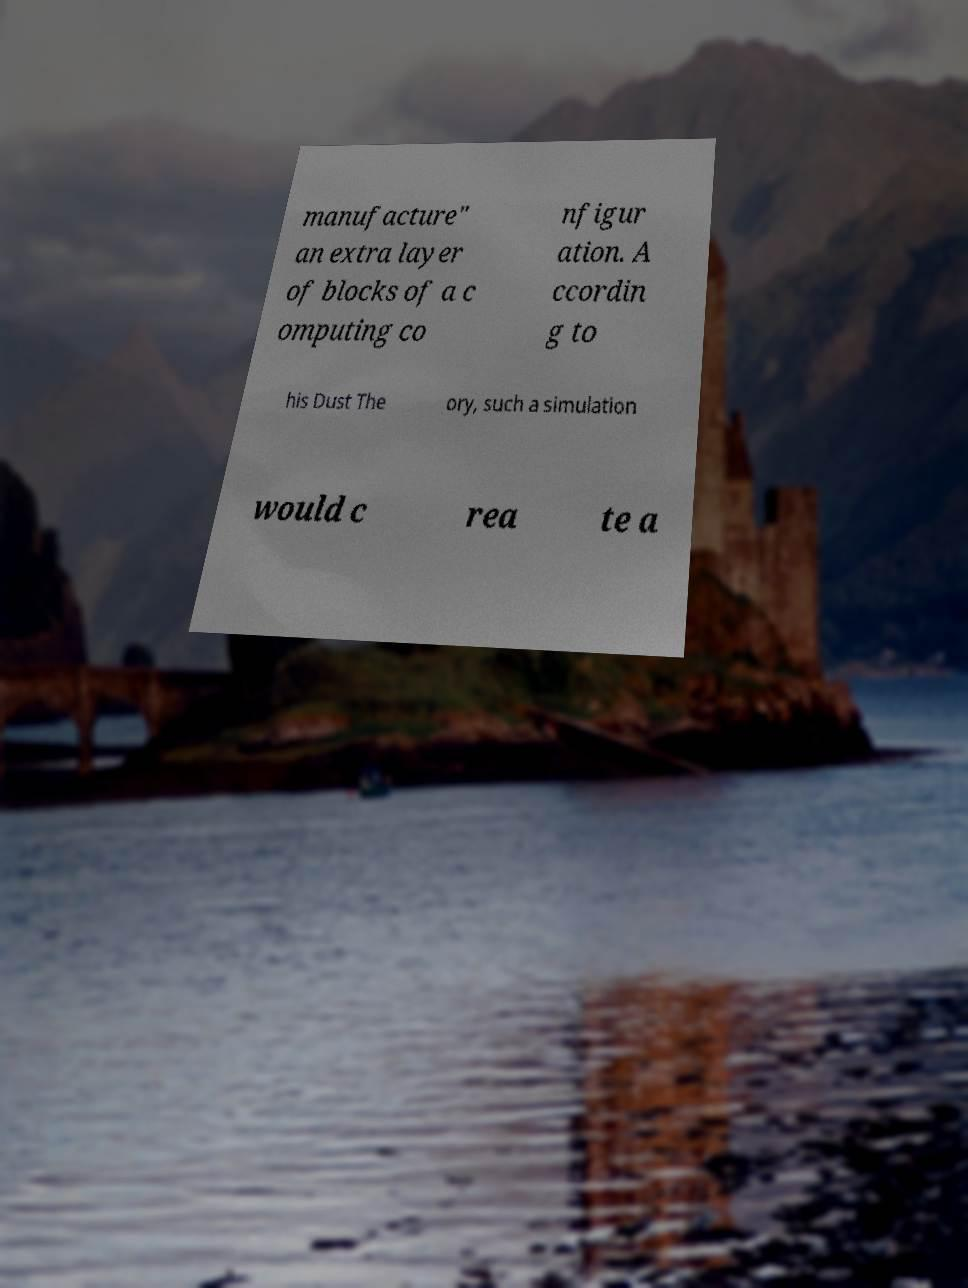Could you extract and type out the text from this image? manufacture" an extra layer of blocks of a c omputing co nfigur ation. A ccordin g to his Dust The ory, such a simulation would c rea te a 